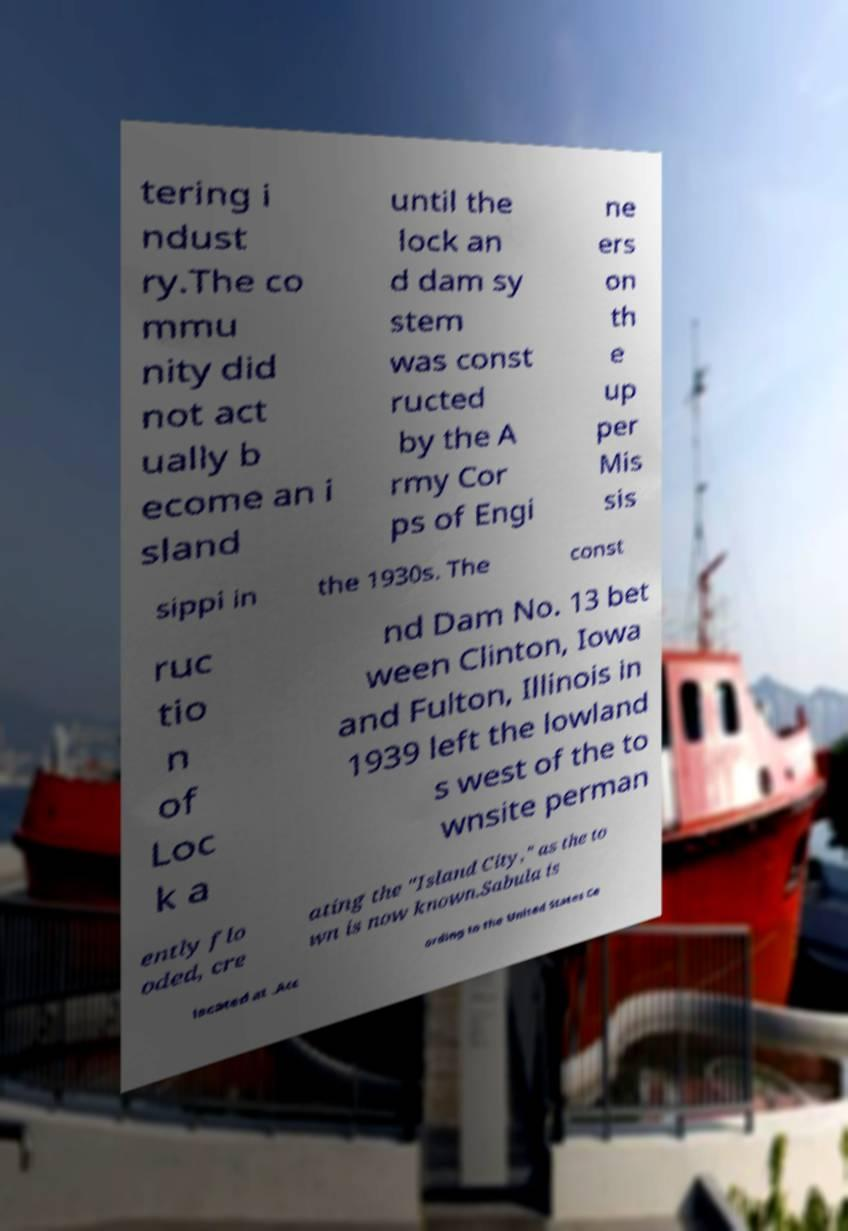What messages or text are displayed in this image? I need them in a readable, typed format. tering i ndust ry.The co mmu nity did not act ually b ecome an i sland until the lock an d dam sy stem was const ructed by the A rmy Cor ps of Engi ne ers on th e up per Mis sis sippi in the 1930s. The const ruc tio n of Loc k a nd Dam No. 13 bet ween Clinton, Iowa and Fulton, Illinois in 1939 left the lowland s west of the to wnsite perman ently flo oded, cre ating the "Island City," as the to wn is now known.Sabula is located at .Acc ording to the United States Ce 